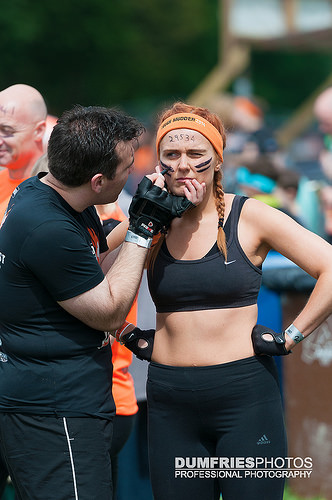<image>
Is the women behind the man? No. The women is not behind the man. From this viewpoint, the women appears to be positioned elsewhere in the scene. Is the wristband to the right of the hip? Yes. From this viewpoint, the wristband is positioned to the right side relative to the hip. 